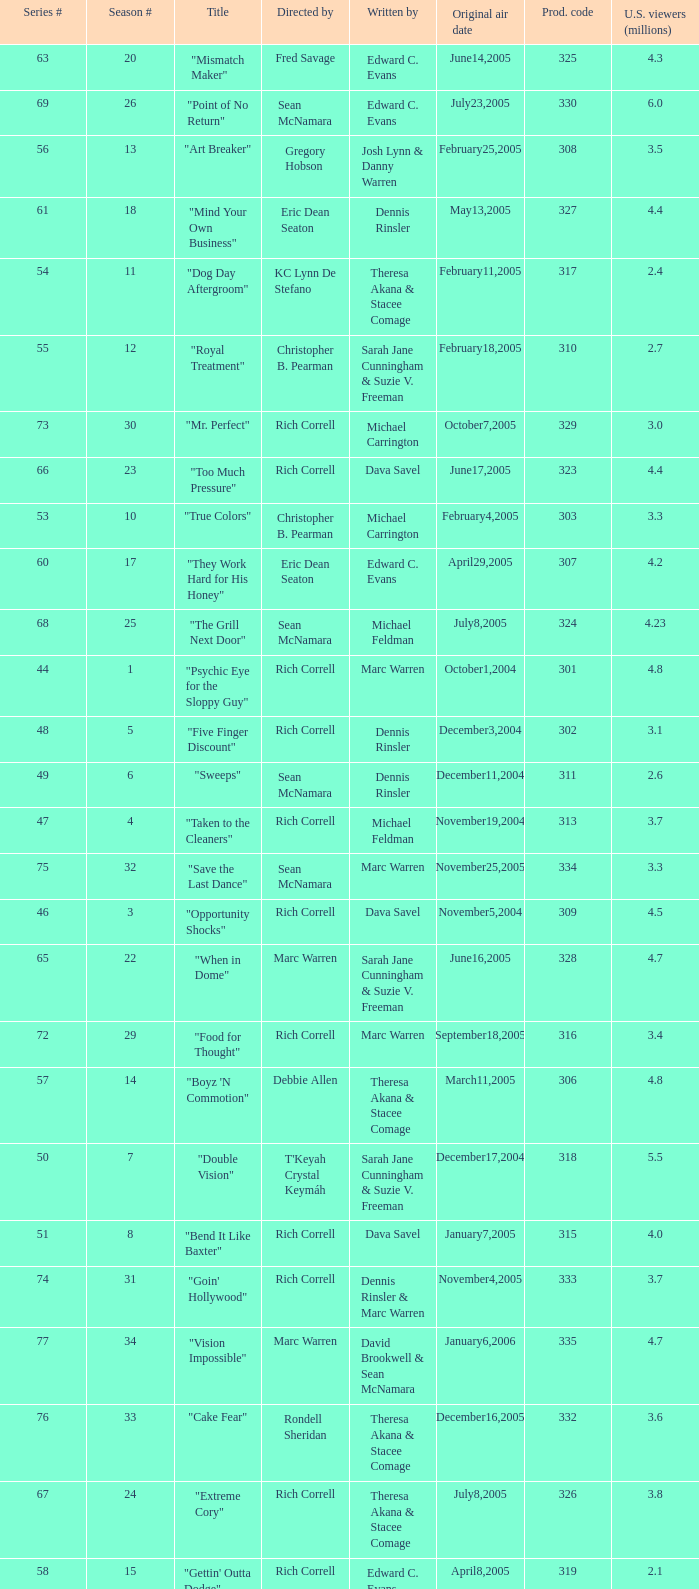Parse the full table. {'header': ['Series #', 'Season #', 'Title', 'Directed by', 'Written by', 'Original air date', 'Prod. code', 'U.S. viewers (millions)'], 'rows': [['63', '20', '"Mismatch Maker"', 'Fred Savage', 'Edward C. Evans', 'June14,2005', '325', '4.3'], ['69', '26', '"Point of No Return"', 'Sean McNamara', 'Edward C. Evans', 'July23,2005', '330', '6.0'], ['56', '13', '"Art Breaker"', 'Gregory Hobson', 'Josh Lynn & Danny Warren', 'February25,2005', '308', '3.5'], ['61', '18', '"Mind Your Own Business"', 'Eric Dean Seaton', 'Dennis Rinsler', 'May13,2005', '327', '4.4'], ['54', '11', '"Dog Day Aftergroom"', 'KC Lynn De Stefano', 'Theresa Akana & Stacee Comage', 'February11,2005', '317', '2.4'], ['55', '12', '"Royal Treatment"', 'Christopher B. Pearman', 'Sarah Jane Cunningham & Suzie V. Freeman', 'February18,2005', '310', '2.7'], ['73', '30', '"Mr. Perfect"', 'Rich Correll', 'Michael Carrington', 'October7,2005', '329', '3.0'], ['66', '23', '"Too Much Pressure"', 'Rich Correll', 'Dava Savel', 'June17,2005', '323', '4.4'], ['53', '10', '"True Colors"', 'Christopher B. Pearman', 'Michael Carrington', 'February4,2005', '303', '3.3'], ['60', '17', '"They Work Hard for His Honey"', 'Eric Dean Seaton', 'Edward C. Evans', 'April29,2005', '307', '4.2'], ['68', '25', '"The Grill Next Door"', 'Sean McNamara', 'Michael Feldman', 'July8,2005', '324', '4.23'], ['44', '1', '"Psychic Eye for the Sloppy Guy"', 'Rich Correll', 'Marc Warren', 'October1,2004', '301', '4.8'], ['48', '5', '"Five Finger Discount"', 'Rich Correll', 'Dennis Rinsler', 'December3,2004', '302', '3.1'], ['49', '6', '"Sweeps"', 'Sean McNamara', 'Dennis Rinsler', 'December11,2004', '311', '2.6'], ['47', '4', '"Taken to the Cleaners"', 'Rich Correll', 'Michael Feldman', 'November19,2004', '313', '3.7'], ['75', '32', '"Save the Last Dance"', 'Sean McNamara', 'Marc Warren', 'November25,2005', '334', '3.3'], ['46', '3', '"Opportunity Shocks"', 'Rich Correll', 'Dava Savel', 'November5,2004', '309', '4.5'], ['65', '22', '"When in Dome"', 'Marc Warren', 'Sarah Jane Cunningham & Suzie V. Freeman', 'June16,2005', '328', '4.7'], ['72', '29', '"Food for Thought"', 'Rich Correll', 'Marc Warren', 'September18,2005', '316', '3.4'], ['57', '14', '"Boyz \'N Commotion"', 'Debbie Allen', 'Theresa Akana & Stacee Comage', 'March11,2005', '306', '4.8'], ['50', '7', '"Double Vision"', "T'Keyah Crystal Keymáh", 'Sarah Jane Cunningham & Suzie V. Freeman', 'December17,2004', '318', '5.5'], ['51', '8', '"Bend It Like Baxter"', 'Rich Correll', 'Dava Savel', 'January7,2005', '315', '4.0'], ['74', '31', '"Goin\' Hollywood"', 'Rich Correll', 'Dennis Rinsler & Marc Warren', 'November4,2005', '333', '3.7'], ['77', '34', '"Vision Impossible"', 'Marc Warren', 'David Brookwell & Sean McNamara', 'January6,2006', '335', '4.7'], ['76', '33', '"Cake Fear"', 'Rondell Sheridan', 'Theresa Akana & Stacee Comage', 'December16,2005', '332', '3.6'], ['67', '24', '"Extreme Cory"', 'Rich Correll', 'Theresa Akana & Stacee Comage', 'July8,2005', '326', '3.8'], ['58', '15', '"Gettin\' Outta Dodge"', 'Rich Correll', 'Edward C. Evans', 'April8,2005', '319', '2.1'], ['45', '2', '"Stark Raven Mad"', 'Marc Warren', 'Sarah Jane Cunningham & Suzie V. Freeman', 'October22,2004', '304', '4.5'], ['59', '16', '"On Top of Old Oakey"', 'John Tracy', 'Michael Feldman', 'April22,2005', '305', '2.3'], ['62', '19', '"Hizzouse Party"', 'Rich Correll', 'Michael Carrington', 'June13,2005', '312', '5.1'], ['52', '9', '"The Big Buzz"', 'Eric Dean Seaton', 'Marc Warren', 'January28,2005', '322', '2.17']]} What is the title of the episode directed by Rich Correll and written by Dennis Rinsler? "Five Finger Discount". 